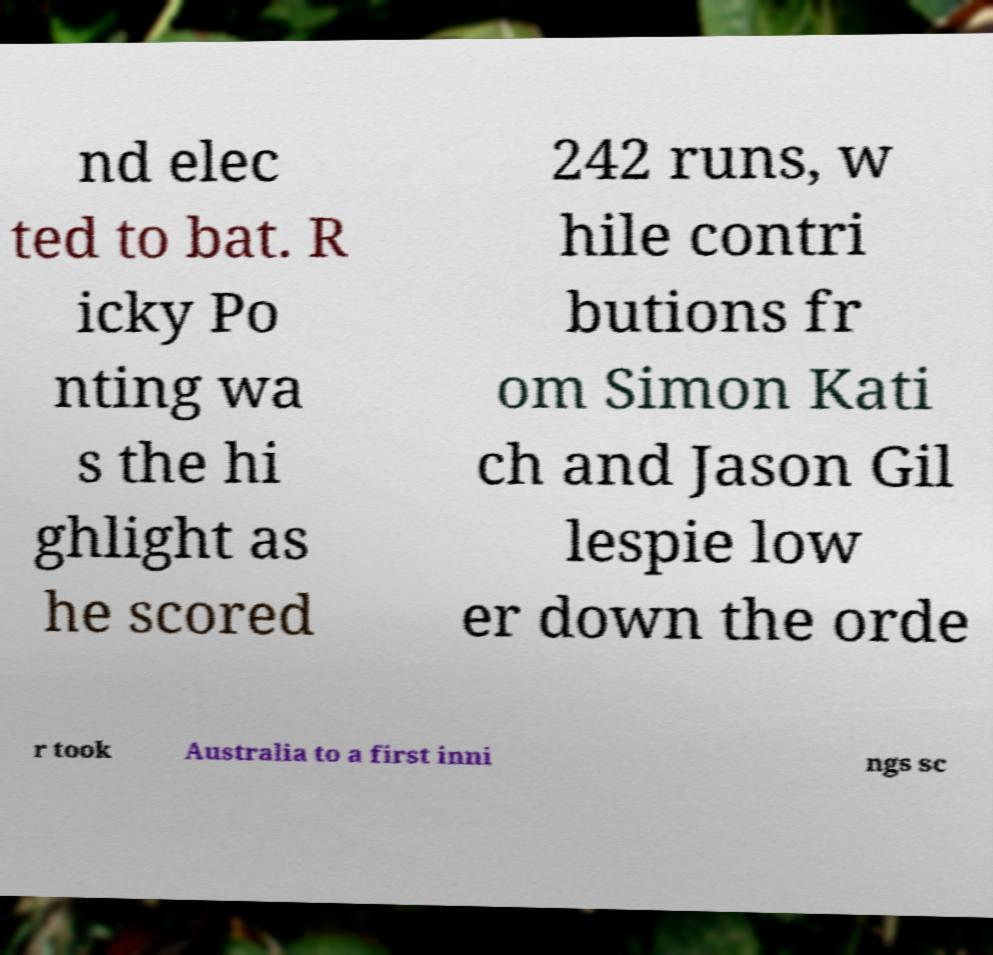What messages or text are displayed in this image? I need them in a readable, typed format. nd elec ted to bat. R icky Po nting wa s the hi ghlight as he scored 242 runs, w hile contri butions fr om Simon Kati ch and Jason Gil lespie low er down the orde r took Australia to a first inni ngs sc 